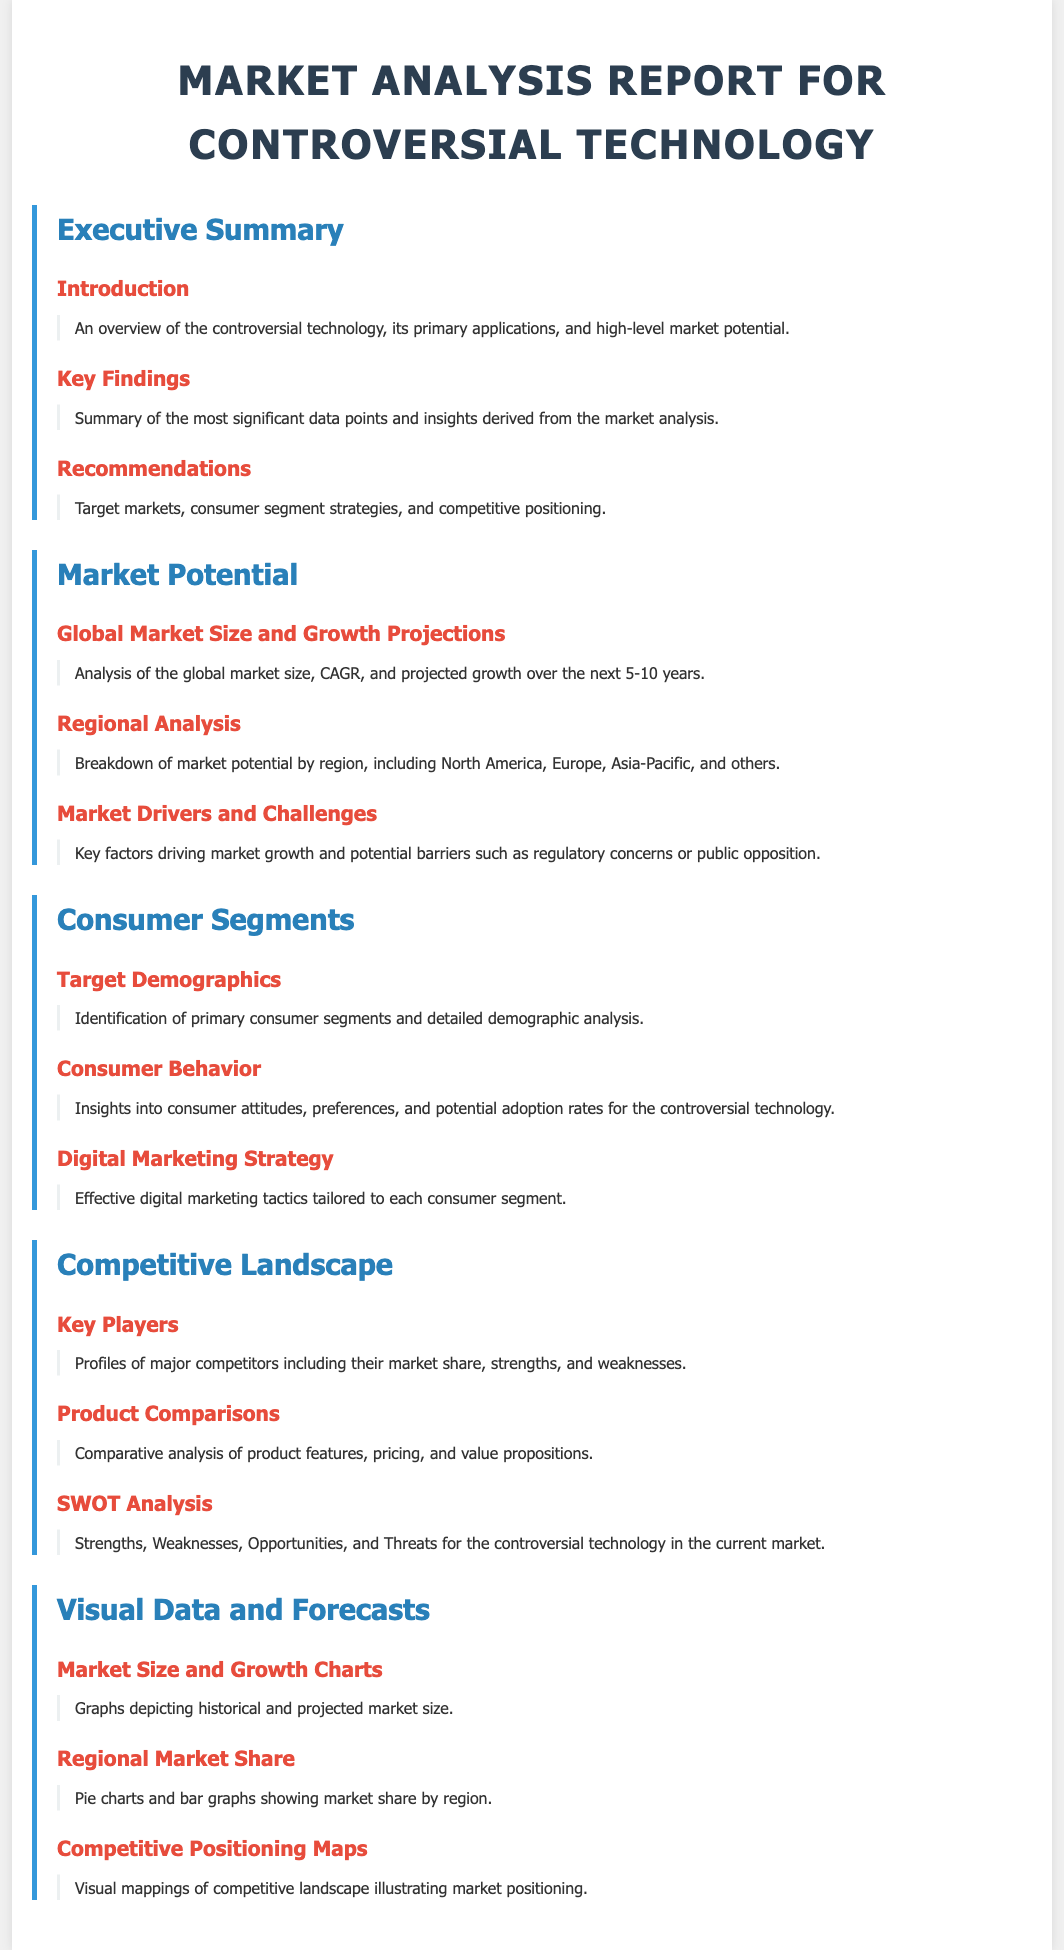what is the title of the document? The title is displayed prominently at the top of the document, summarizing the content.
Answer: Market Analysis Report for Controversial Technology what are the main demographics discussed? The section on consumer segments outlines the primary consumer groups and their characteristics.
Answer: Target Demographics how many sections are in the document? The document contains a total of five main sections each covering different aspects of market analysis.
Answer: Five what is the focus of the 'SWOT Analysis'? This part of the document analyzes internal and external factors affecting controversial technology's market presence.
Answer: Strengths, Weaknesses, Opportunities, Threats which region is included in the market potential analysis? The document lists specific geographic areas that contribute to the overall market potential discussion.
Answer: North America, Europe, Asia-Pacific, others what type of visual data is provided in the report? The report includes various visual representations to highlight findings and projections clearly.
Answer: Market Size and Growth Charts what key factor is likely to challenge market growth? These challenges are discussed in relation to external influences that could hinder the success of the technology.
Answer: Regulatory concerns what strategy does the document suggest for digital marketing? This section includes recommendations tailored to how to effectively reach specific consumer segments.
Answer: Effective digital marketing tactics what is the projected growth period stated in the document? The market growth projections extend over a defined future timeframe.
Answer: Next 5-10 years 